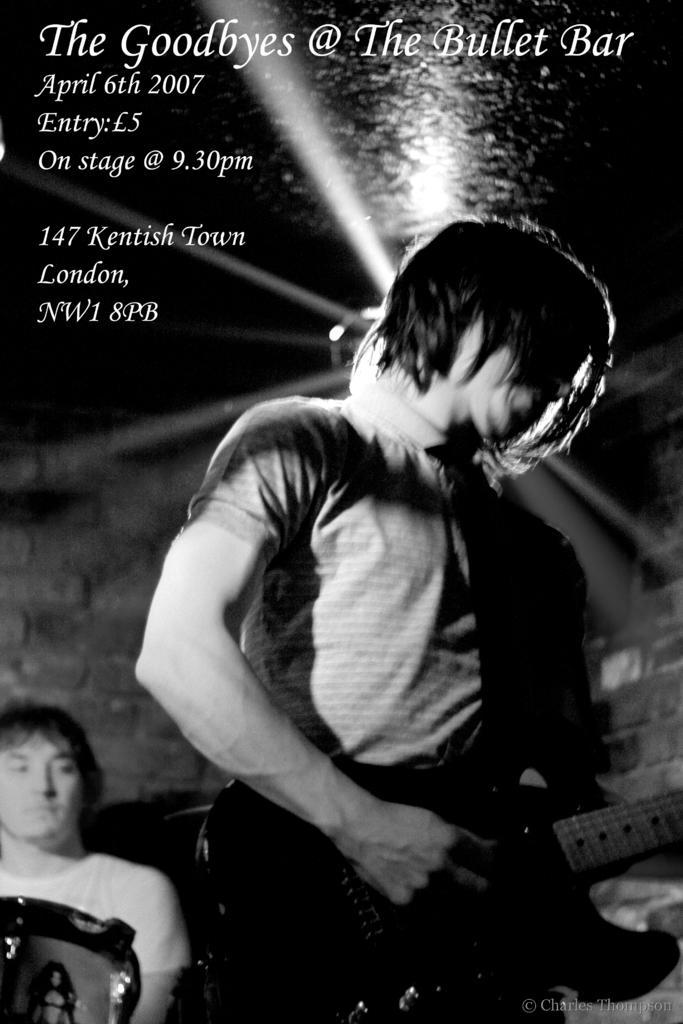Please provide a concise description of this image. In this picture we can see man holding guitar in his hand and playing it and at back of him other man looking at him and in background we can see wall, light and it is dark and this is a poster. 